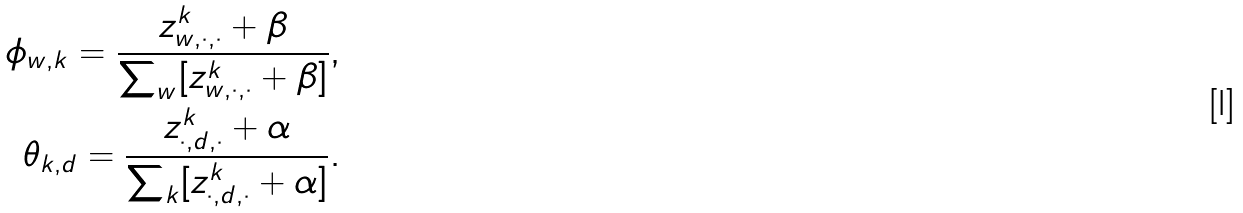<formula> <loc_0><loc_0><loc_500><loc_500>\phi _ { w , k } = \frac { z ^ { k } _ { w , \cdot , \cdot } + \beta } { \sum _ { w } [ z ^ { k } _ { w , \cdot , \cdot } + \beta ] } , \\ \theta _ { k , d } = \frac { z ^ { k } _ { \cdot , d , \cdot } + \alpha } { \sum _ { k } [ z ^ { k } _ { \cdot , d , \cdot } + \alpha ] } .</formula> 